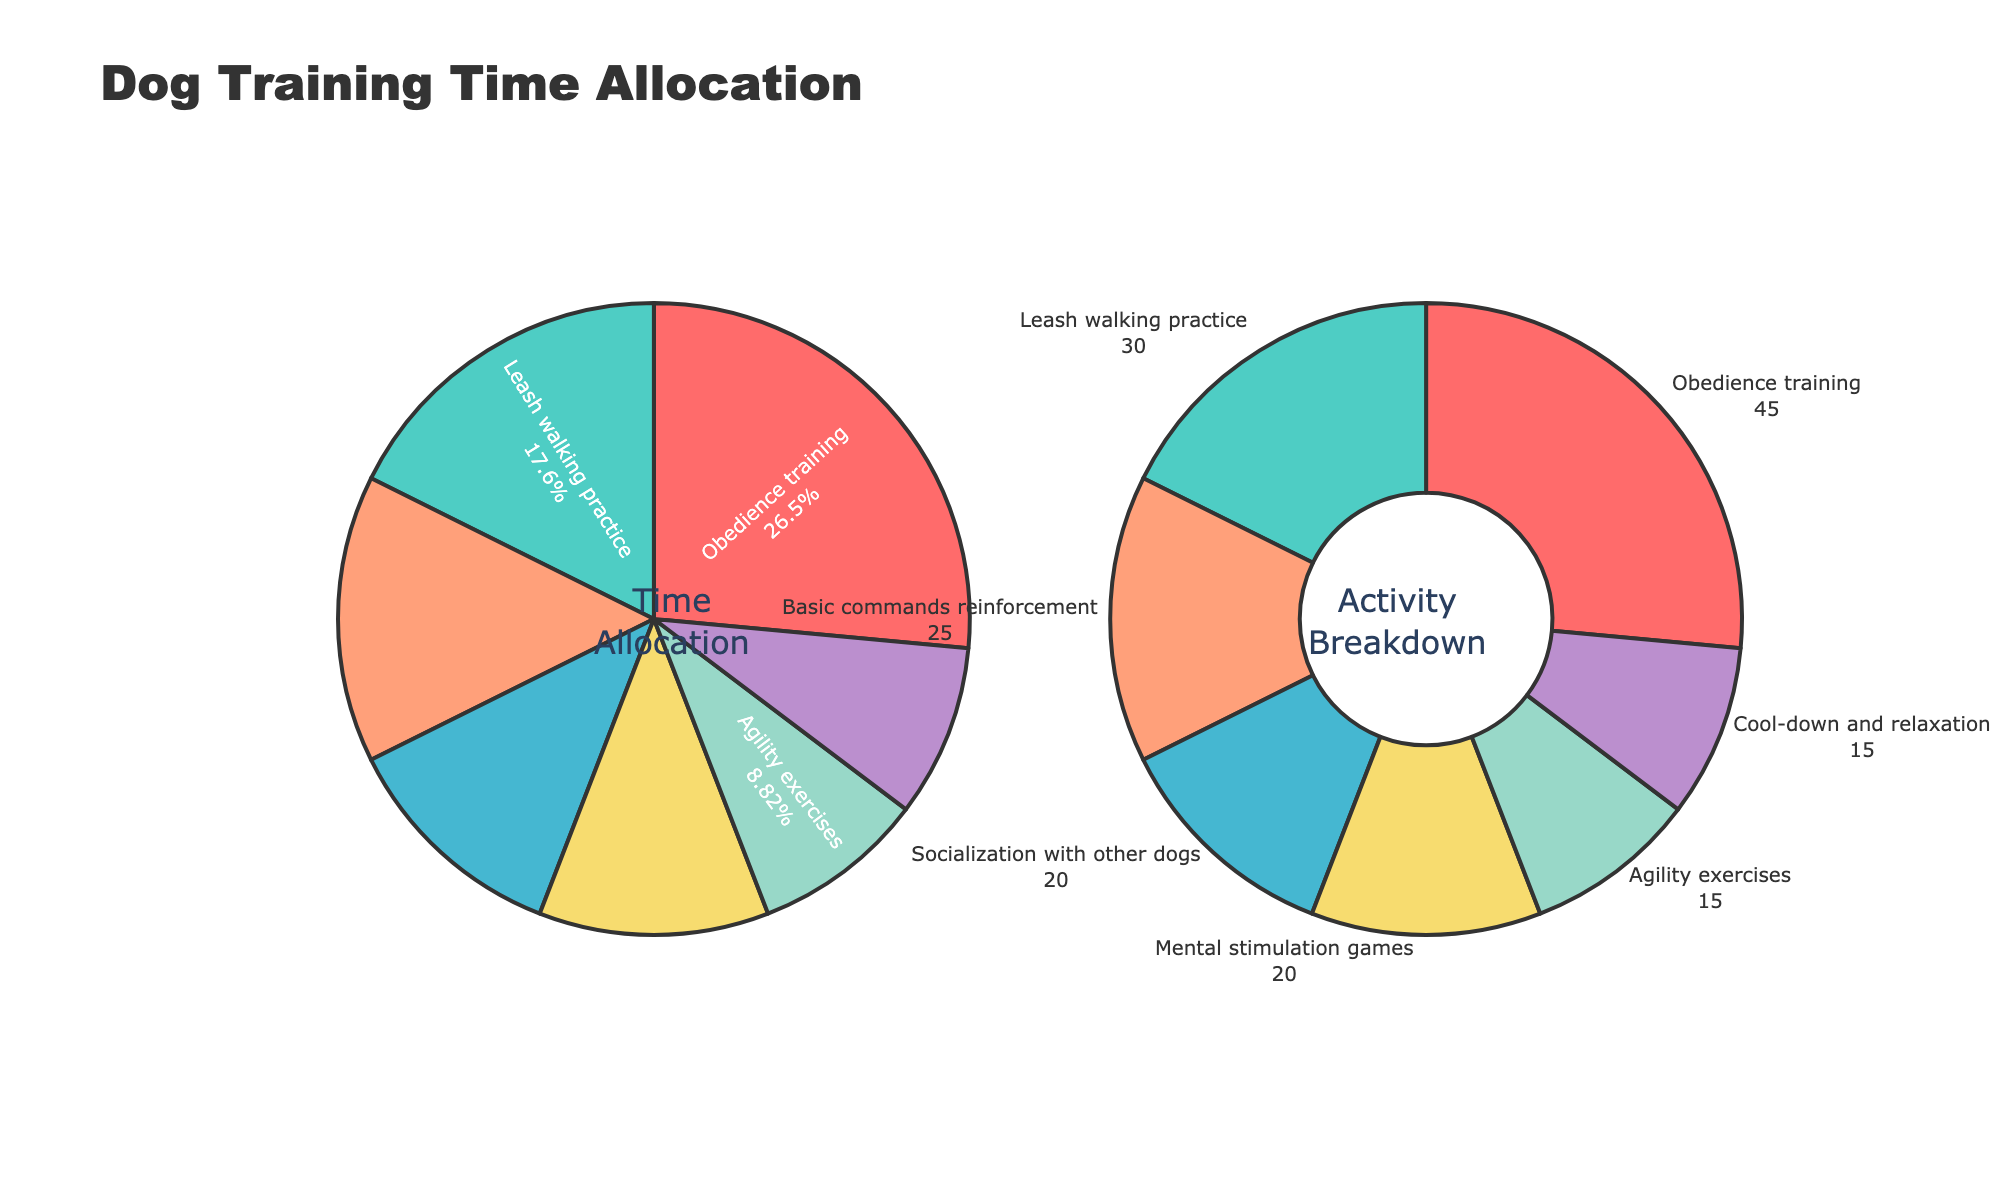What is the title of the figure? The title is located at the top of the figure and reads "Dog Training Time Allocation"
Answer: Dog Training Time Allocation How many different activities are represented in the pie charts? By counting the labels in either pie chart, we can see there are 7 different activities represented
Answer: 7 What percentage of time is allocated to "Obedience training" in the Time Allocation pie chart? In the first pie chart, locate "Obedience training" and read its associated percentage from the chart. It is 28.8%.
Answer: 28.8% Which activity has the smallest time allocation, and what is the allocated time? The activity with the smallest allocation is the one with the smallest segment in either pie chart. "Agility exercises" has the smallest time allocation of 15 minutes
Answer: Agility exercises, 15 minutes How does the representation of activities differ between the two pie charts? The first pie chart uses segment size and percentage labels to show time allocation, whereas the second pie chart uses segment size and value labels, also employing a hole in the center
Answer: Different labeling and presence of a hole in the second chart Which activities have an equal allocation of time, and what is that time? Look for activities with equal segment sizes and corresponding values in the pie charts. "Mental stimulation games" and "Socialization with other dogs" both have an allocation of 20 minutes
Answer: Mental stimulation games, Socialization with other dogs, 20 minutes What is the total time allocated for Basic commands reinforcement and Agility exercises? Sum the allocated times for "Basic commands reinforcement" (25 minutes) and "Agility exercises" (15 minutes): 25 + 15 = 40 minutes
Answer: 40 minutes Which activity takes up less time, Socialization with other dogs or Leash walking practice? Compare the allocated times in either pie chart. "Socialization with other dogs" (20 minutes) takes less time than "Leash walking practice" (30 minutes)
Answer: Socialization with other dogs What is the sum of time allocated to Cool-down and relaxation, and Mental stimulation games? Add the values of time allocated to "Cool-down and relaxation" (15 minutes) and "Mental stimulation games" (20 minutes), resulting in 15 + 20 = 35
Answer: 35 What fraction of the total training time is allocated to Obedience training? The total training time is the sum of all allocated times, 45 + 30 + 20 + 25 + 15 + 20 + 15 = 170 minutes. The fraction for Obedience training is 45/170
Answer: 45/170 